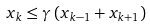<formula> <loc_0><loc_0><loc_500><loc_500>x _ { k } \leq \gamma \left ( x _ { k - 1 } + x _ { k + 1 } \right )</formula> 